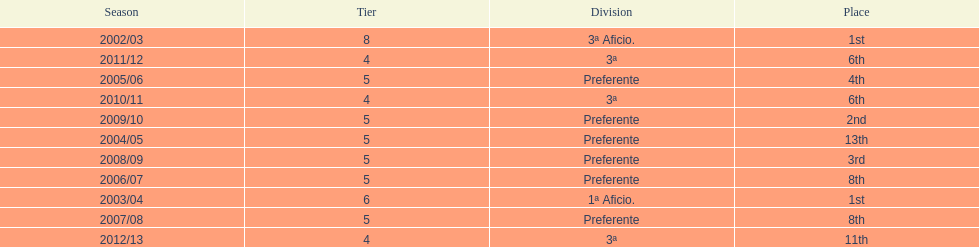How many times did internacional de madrid cf end the season at the top of their division? 2. 